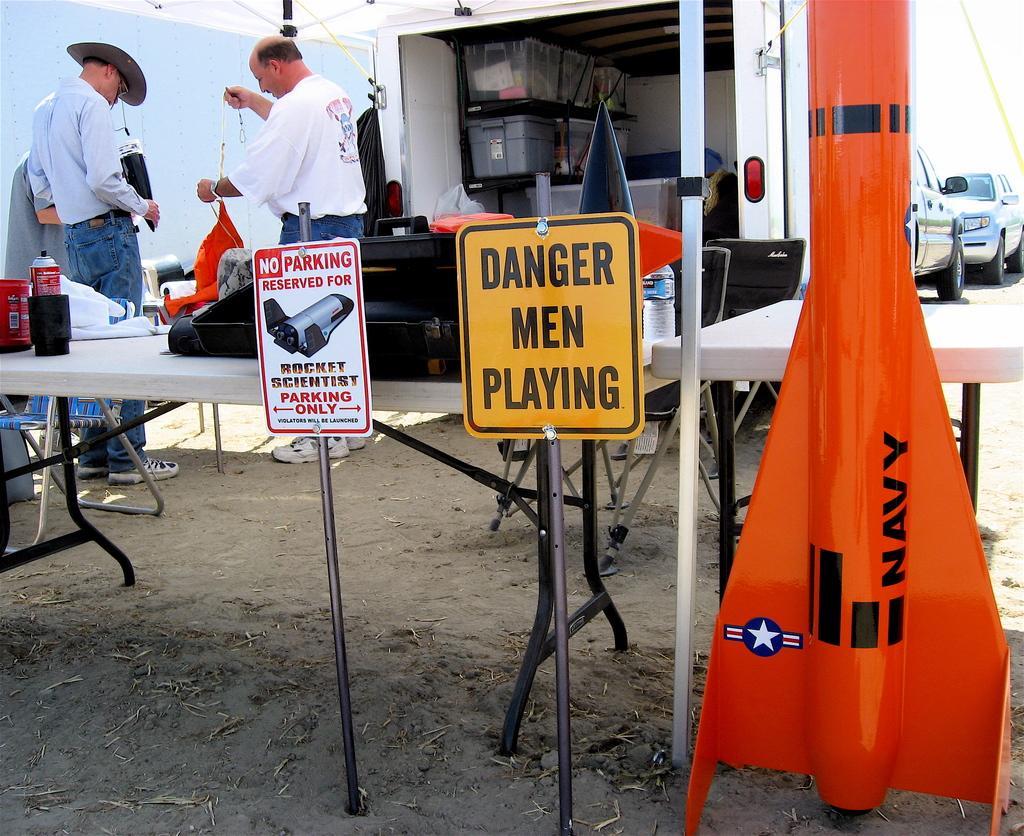In one or two sentences, can you explain what this image depicts? In the left middle, two person are standing and holding an object in their hand. Below to that a table is there on which can, bottle and machine is kept. In the middle, truck is there in which boxes are kept. On the right, two cars are visible. In the middle two boards are there and in the right rocket is visible of orange in color. At the bottom ground is visible. This image is taken inside an umbrella hut during day time in a sky. 